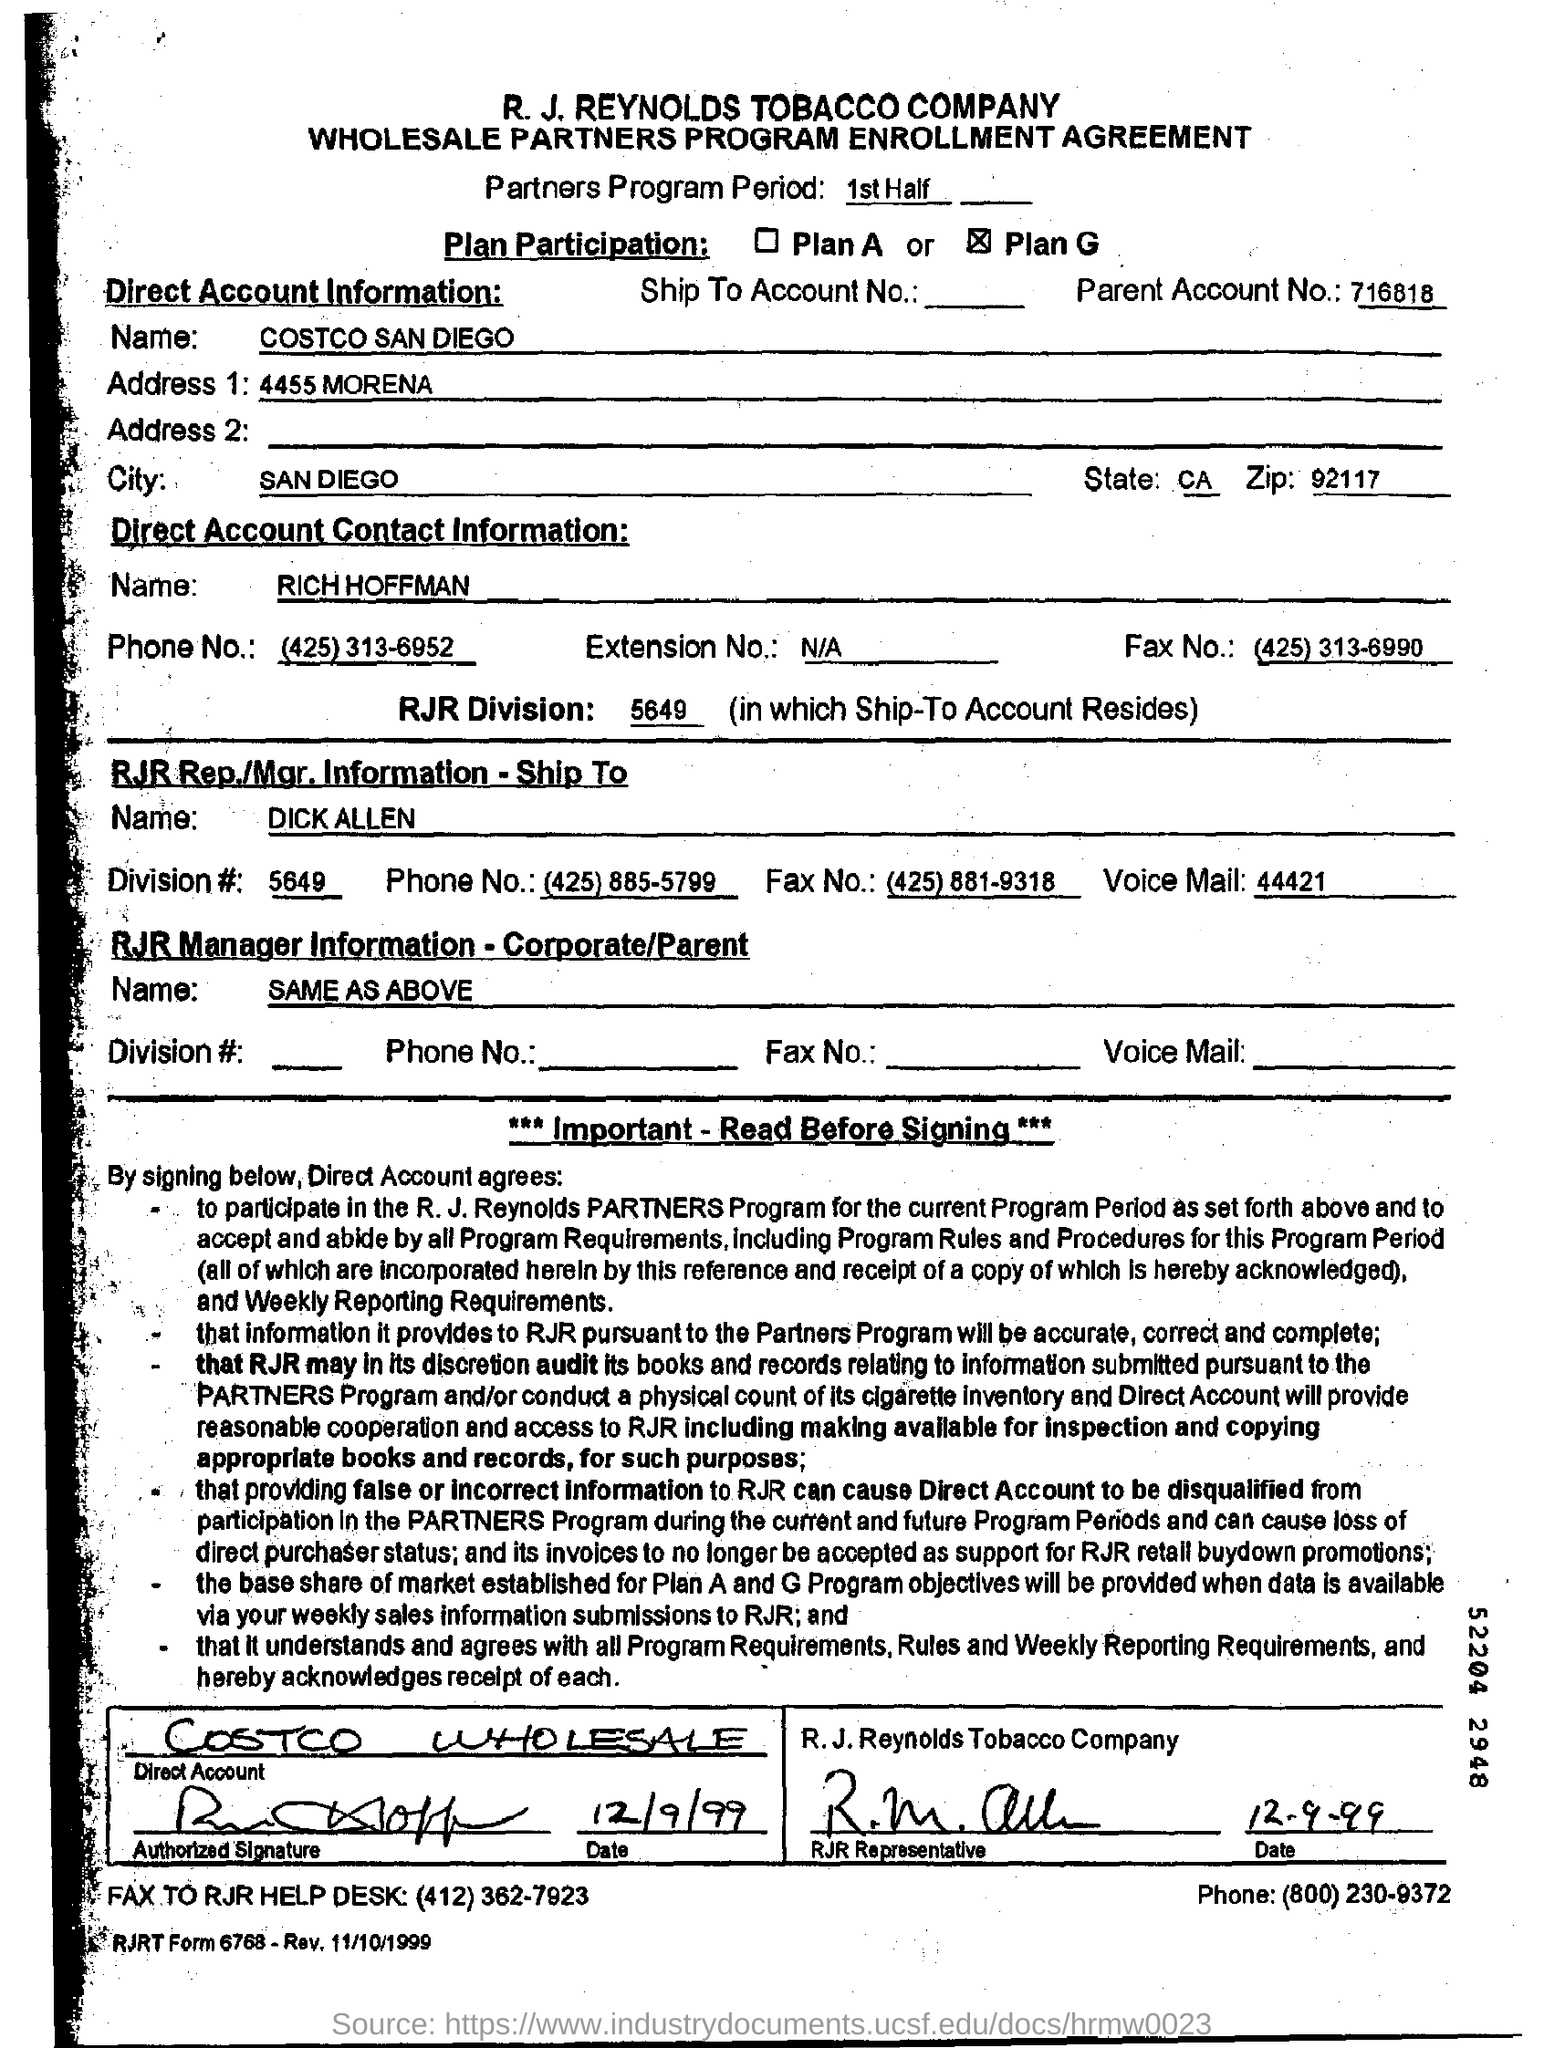Identify some key points in this picture. The Zip Code Number for 92117 is... The RJR Division Number is 5649. The parent account number is 716818.... The name of the company is R. J. Reynolds Tobacco Company. The parent account number is 716818.... 